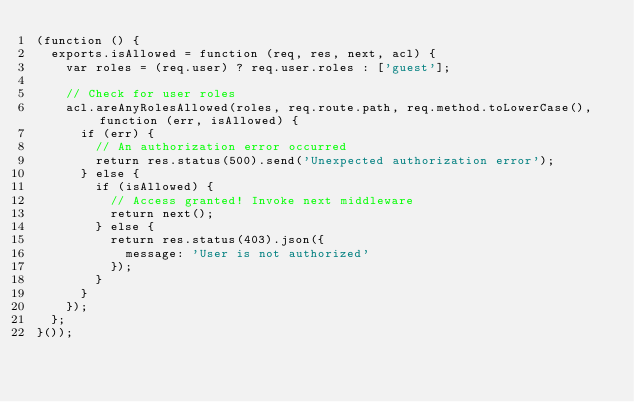<code> <loc_0><loc_0><loc_500><loc_500><_JavaScript_>(function () {
  exports.isAllowed = function (req, res, next, acl) {
    var roles = (req.user) ? req.user.roles : ['guest'];

    // Check for user roles
    acl.areAnyRolesAllowed(roles, req.route.path, req.method.toLowerCase(), function (err, isAllowed) {
      if (err) {
        // An authorization error occurred
        return res.status(500).send('Unexpected authorization error');
      } else {
        if (isAllowed) {
          // Access granted! Invoke next middleware
          return next();
        } else {
          return res.status(403).json({
            message: 'User is not authorized'
          });
        }
      }
    });
  };
}());
</code> 